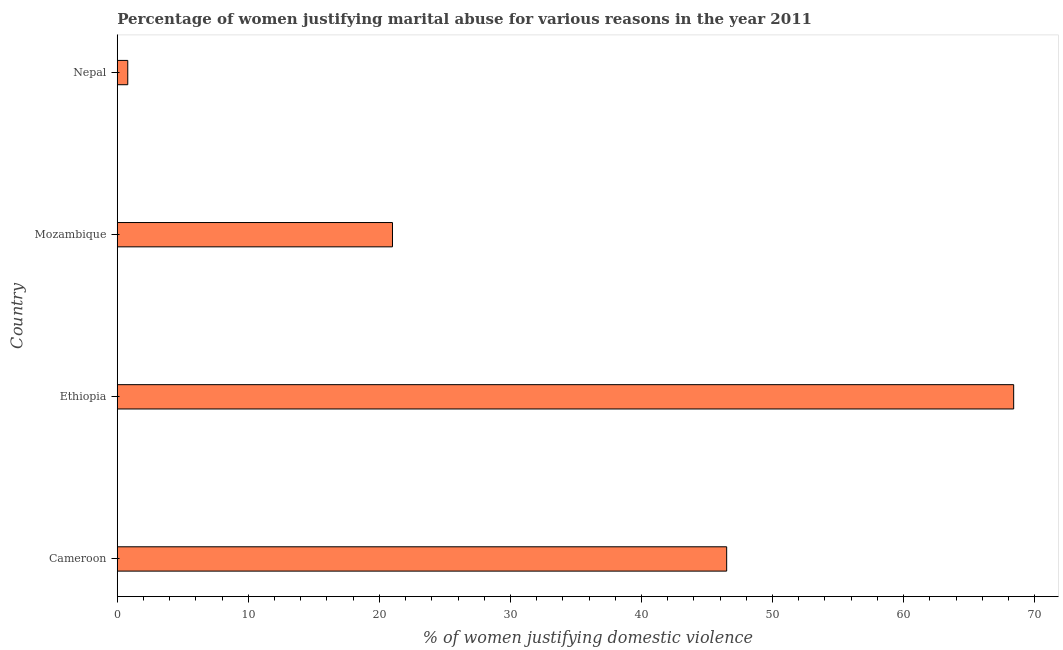Does the graph contain grids?
Keep it short and to the point. No. What is the title of the graph?
Give a very brief answer. Percentage of women justifying marital abuse for various reasons in the year 2011. What is the label or title of the X-axis?
Provide a succinct answer. % of women justifying domestic violence. What is the label or title of the Y-axis?
Provide a short and direct response. Country. What is the percentage of women justifying marital abuse in Nepal?
Your answer should be compact. 0.8. Across all countries, what is the maximum percentage of women justifying marital abuse?
Offer a very short reply. 68.4. Across all countries, what is the minimum percentage of women justifying marital abuse?
Provide a short and direct response. 0.8. In which country was the percentage of women justifying marital abuse maximum?
Give a very brief answer. Ethiopia. In which country was the percentage of women justifying marital abuse minimum?
Give a very brief answer. Nepal. What is the sum of the percentage of women justifying marital abuse?
Offer a terse response. 136.7. What is the difference between the percentage of women justifying marital abuse in Cameroon and Ethiopia?
Give a very brief answer. -21.9. What is the average percentage of women justifying marital abuse per country?
Your response must be concise. 34.17. What is the median percentage of women justifying marital abuse?
Offer a terse response. 33.75. In how many countries, is the percentage of women justifying marital abuse greater than 30 %?
Offer a very short reply. 2. What is the ratio of the percentage of women justifying marital abuse in Cameroon to that in Ethiopia?
Make the answer very short. 0.68. Is the percentage of women justifying marital abuse in Ethiopia less than that in Nepal?
Provide a short and direct response. No. What is the difference between the highest and the second highest percentage of women justifying marital abuse?
Give a very brief answer. 21.9. Is the sum of the percentage of women justifying marital abuse in Cameroon and Ethiopia greater than the maximum percentage of women justifying marital abuse across all countries?
Offer a very short reply. Yes. What is the difference between the highest and the lowest percentage of women justifying marital abuse?
Your answer should be compact. 67.6. How many bars are there?
Your answer should be very brief. 4. How many countries are there in the graph?
Offer a very short reply. 4. What is the % of women justifying domestic violence of Cameroon?
Your response must be concise. 46.5. What is the % of women justifying domestic violence in Ethiopia?
Make the answer very short. 68.4. What is the difference between the % of women justifying domestic violence in Cameroon and Ethiopia?
Provide a succinct answer. -21.9. What is the difference between the % of women justifying domestic violence in Cameroon and Nepal?
Ensure brevity in your answer.  45.7. What is the difference between the % of women justifying domestic violence in Ethiopia and Mozambique?
Give a very brief answer. 47.4. What is the difference between the % of women justifying domestic violence in Ethiopia and Nepal?
Make the answer very short. 67.6. What is the difference between the % of women justifying domestic violence in Mozambique and Nepal?
Your response must be concise. 20.2. What is the ratio of the % of women justifying domestic violence in Cameroon to that in Ethiopia?
Provide a succinct answer. 0.68. What is the ratio of the % of women justifying domestic violence in Cameroon to that in Mozambique?
Your answer should be very brief. 2.21. What is the ratio of the % of women justifying domestic violence in Cameroon to that in Nepal?
Provide a succinct answer. 58.12. What is the ratio of the % of women justifying domestic violence in Ethiopia to that in Mozambique?
Ensure brevity in your answer.  3.26. What is the ratio of the % of women justifying domestic violence in Ethiopia to that in Nepal?
Make the answer very short. 85.5. What is the ratio of the % of women justifying domestic violence in Mozambique to that in Nepal?
Your response must be concise. 26.25. 